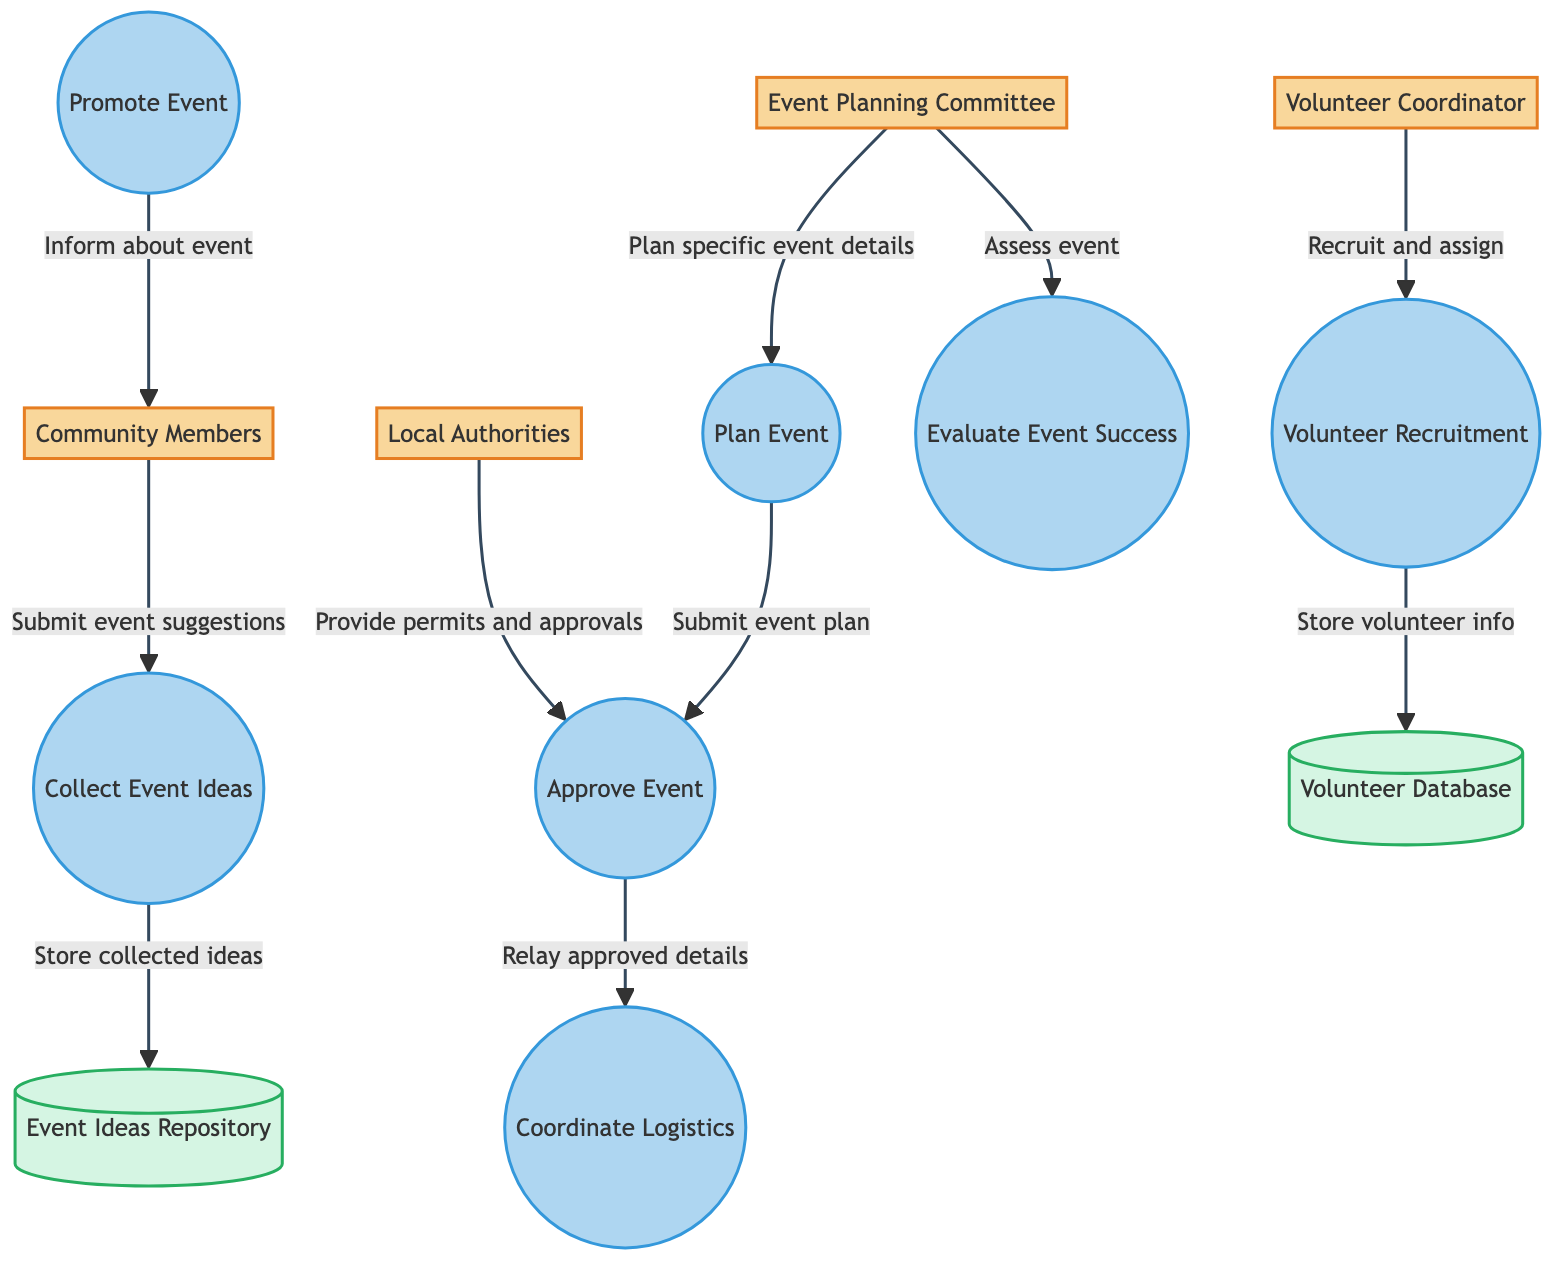What are the entities involved in the event planning process? The diagram includes six entities: Community Members, Event Planning Committee, Local Authorities, Volunteer Coordinator, Sponsors, and Venues. Each entity plays a distinct role in the planning and execution of community events.
Answer: Community Members, Event Planning Committee, Local Authorities, Volunteer Coordinator, Sponsors, Venues How many processes are listed in the diagram? The diagram outlines seven processes: Collect Event Ideas, Plan Event, Volunteer Recruitment, Approve Event, Coordinate Logistics, Promote Event, and Evaluate Event Success. Counting these processes gives us the total.
Answer: Seven What does the Volunteer Coordinator do according to the diagram? The Volunteer Coordinator is responsible for recruiting and assigning volunteers for events, as the flow indicates this role directly leads to the Volunteer Recruitment process.
Answer: Recruit and assign volunteers Which two entities provide input to the Approve Event process? The two entities that provide input to the Approve Event process are the Event Planning Committee and Local Authorities. The flow shows that both send necessary information for event approval.
Answer: Event Planning Committee, Local Authorities What is stored in the Event Ideas Repository? The Event Ideas Repository stores collected event ideas that have been submitted by community members through the Collect Event Ideas process. This is indicated by the data flow between these two components.
Answer: Event suggestions What is the relationship between Evaluate Event Success and Event Planning Committee? The Event Planning Committee assesses the event's performance based on feedback and other metrics, as indicated by the direct flow from the Event Planning Committee to the Evaluate Event Success process.
Answer: Assess event performance Which process comes immediately after the event is planned? The process that comes immediately after the Plan Event process is the Approve Event process. The diagram shows the direct sequence between these two processes, with Plan Event leading to Approve Event.
Answer: Approve Event How do Community Members receive information about events? Community Members receive information about events through the Promote Event process, which informs them about upcoming community activities. This is shown as a direct data flow from Promote Event to Community Members.
Answer: Inform about the event What type of data is kept in the Volunteer Database? The Volunteer Database retains records of recruited volunteers and their assigned tasks. This association is explicit in the flow from the Volunteer Recruitment process to the Volunteer Database.
Answer: Volunteer information and assignments 